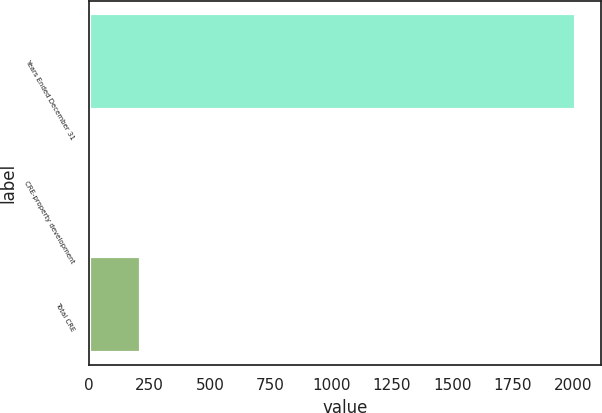Convert chart to OTSL. <chart><loc_0><loc_0><loc_500><loc_500><bar_chart><fcel>Years Ended December 31<fcel>CRE-property development<fcel>Total CRE<nl><fcel>2012<fcel>16<fcel>215.6<nl></chart> 